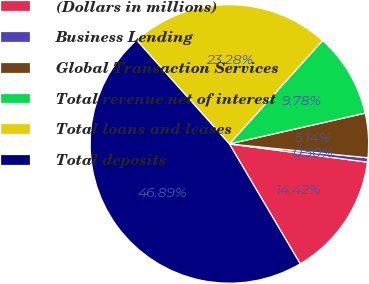Convert chart to OTSL. <chart><loc_0><loc_0><loc_500><loc_500><pie_chart><fcel>(Dollars in millions)<fcel>Business Lending<fcel>Global Transaction Services<fcel>Total revenue net of interest<fcel>Total loans and leases<fcel>Total deposits<nl><fcel>14.42%<fcel>0.5%<fcel>5.14%<fcel>9.78%<fcel>23.28%<fcel>46.89%<nl></chart> 